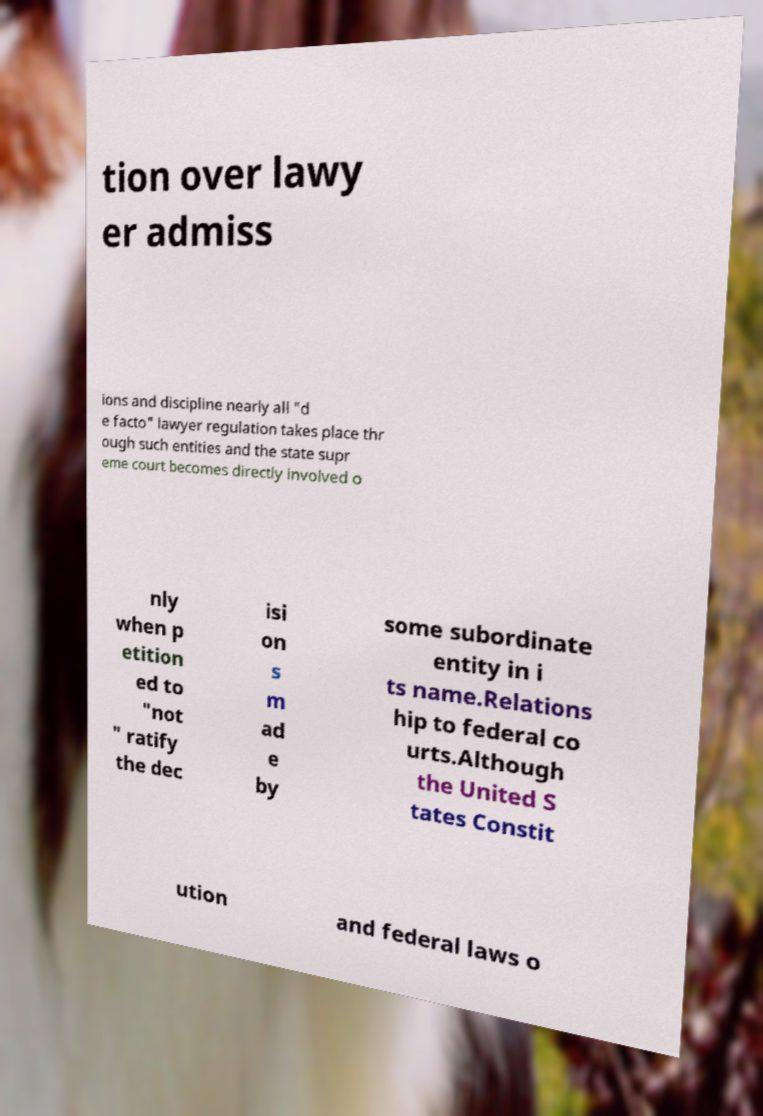Please read and relay the text visible in this image. What does it say? tion over lawy er admiss ions and discipline nearly all "d e facto" lawyer regulation takes place thr ough such entities and the state supr eme court becomes directly involved o nly when p etition ed to "not " ratify the dec isi on s m ad e by some subordinate entity in i ts name.Relations hip to federal co urts.Although the United S tates Constit ution and federal laws o 